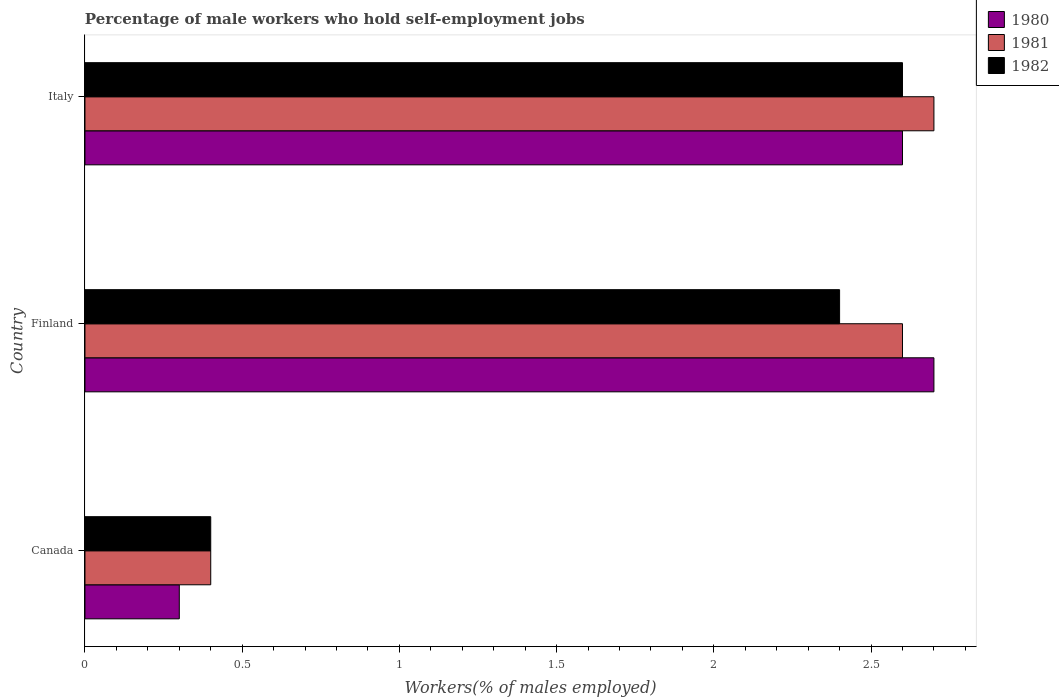How many different coloured bars are there?
Your response must be concise. 3. How many groups of bars are there?
Provide a succinct answer. 3. Are the number of bars per tick equal to the number of legend labels?
Your response must be concise. Yes. How many bars are there on the 3rd tick from the top?
Provide a succinct answer. 3. How many bars are there on the 2nd tick from the bottom?
Provide a short and direct response. 3. What is the label of the 2nd group of bars from the top?
Provide a short and direct response. Finland. In how many cases, is the number of bars for a given country not equal to the number of legend labels?
Provide a short and direct response. 0. What is the percentage of self-employed male workers in 1981 in Italy?
Offer a terse response. 2.7. Across all countries, what is the maximum percentage of self-employed male workers in 1982?
Ensure brevity in your answer.  2.6. Across all countries, what is the minimum percentage of self-employed male workers in 1980?
Your answer should be compact. 0.3. What is the total percentage of self-employed male workers in 1982 in the graph?
Make the answer very short. 5.4. What is the difference between the percentage of self-employed male workers in 1981 in Canada and that in Finland?
Keep it short and to the point. -2.2. What is the difference between the percentage of self-employed male workers in 1981 in Italy and the percentage of self-employed male workers in 1982 in Finland?
Your answer should be very brief. 0.3. What is the average percentage of self-employed male workers in 1980 per country?
Keep it short and to the point. 1.87. What is the difference between the percentage of self-employed male workers in 1981 and percentage of self-employed male workers in 1980 in Canada?
Offer a terse response. 0.1. What is the ratio of the percentage of self-employed male workers in 1982 in Canada to that in Finland?
Ensure brevity in your answer.  0.17. What is the difference between the highest and the second highest percentage of self-employed male workers in 1980?
Your response must be concise. 0.1. What is the difference between the highest and the lowest percentage of self-employed male workers in 1981?
Your answer should be compact. 2.3. In how many countries, is the percentage of self-employed male workers in 1980 greater than the average percentage of self-employed male workers in 1980 taken over all countries?
Give a very brief answer. 2. Is the sum of the percentage of self-employed male workers in 1982 in Canada and Finland greater than the maximum percentage of self-employed male workers in 1980 across all countries?
Make the answer very short. Yes. Are all the bars in the graph horizontal?
Provide a succinct answer. Yes. How many countries are there in the graph?
Provide a short and direct response. 3. Does the graph contain any zero values?
Your response must be concise. No. Does the graph contain grids?
Ensure brevity in your answer.  No. How many legend labels are there?
Give a very brief answer. 3. How are the legend labels stacked?
Ensure brevity in your answer.  Vertical. What is the title of the graph?
Your answer should be compact. Percentage of male workers who hold self-employment jobs. Does "1993" appear as one of the legend labels in the graph?
Offer a very short reply. No. What is the label or title of the X-axis?
Your response must be concise. Workers(% of males employed). What is the Workers(% of males employed) in 1980 in Canada?
Your response must be concise. 0.3. What is the Workers(% of males employed) of 1981 in Canada?
Give a very brief answer. 0.4. What is the Workers(% of males employed) of 1982 in Canada?
Your response must be concise. 0.4. What is the Workers(% of males employed) in 1980 in Finland?
Your response must be concise. 2.7. What is the Workers(% of males employed) in 1981 in Finland?
Offer a terse response. 2.6. What is the Workers(% of males employed) in 1982 in Finland?
Provide a succinct answer. 2.4. What is the Workers(% of males employed) of 1980 in Italy?
Provide a succinct answer. 2.6. What is the Workers(% of males employed) of 1981 in Italy?
Make the answer very short. 2.7. What is the Workers(% of males employed) in 1982 in Italy?
Your answer should be very brief. 2.6. Across all countries, what is the maximum Workers(% of males employed) of 1980?
Give a very brief answer. 2.7. Across all countries, what is the maximum Workers(% of males employed) of 1981?
Provide a succinct answer. 2.7. Across all countries, what is the maximum Workers(% of males employed) in 1982?
Keep it short and to the point. 2.6. Across all countries, what is the minimum Workers(% of males employed) of 1980?
Your answer should be very brief. 0.3. Across all countries, what is the minimum Workers(% of males employed) of 1981?
Give a very brief answer. 0.4. Across all countries, what is the minimum Workers(% of males employed) in 1982?
Your response must be concise. 0.4. What is the total Workers(% of males employed) of 1980 in the graph?
Your response must be concise. 5.6. What is the total Workers(% of males employed) of 1981 in the graph?
Make the answer very short. 5.7. What is the total Workers(% of males employed) of 1982 in the graph?
Provide a succinct answer. 5.4. What is the difference between the Workers(% of males employed) in 1982 in Canada and that in Finland?
Make the answer very short. -2. What is the difference between the Workers(% of males employed) of 1980 in Canada and that in Italy?
Offer a very short reply. -2.3. What is the difference between the Workers(% of males employed) in 1981 in Canada and that in Italy?
Offer a terse response. -2.3. What is the difference between the Workers(% of males employed) of 1982 in Canada and that in Italy?
Make the answer very short. -2.2. What is the difference between the Workers(% of males employed) of 1980 in Finland and that in Italy?
Offer a very short reply. 0.1. What is the difference between the Workers(% of males employed) of 1980 in Canada and the Workers(% of males employed) of 1981 in Finland?
Provide a succinct answer. -2.3. What is the difference between the Workers(% of males employed) of 1980 in Canada and the Workers(% of males employed) of 1982 in Finland?
Your answer should be very brief. -2.1. What is the difference between the Workers(% of males employed) of 1980 in Finland and the Workers(% of males employed) of 1982 in Italy?
Make the answer very short. 0.1. What is the average Workers(% of males employed) in 1980 per country?
Your answer should be very brief. 1.87. What is the average Workers(% of males employed) of 1981 per country?
Your answer should be very brief. 1.9. What is the average Workers(% of males employed) of 1982 per country?
Your answer should be compact. 1.8. What is the difference between the Workers(% of males employed) of 1980 and Workers(% of males employed) of 1981 in Canada?
Your answer should be very brief. -0.1. What is the difference between the Workers(% of males employed) in 1980 and Workers(% of males employed) in 1982 in Canada?
Your response must be concise. -0.1. What is the difference between the Workers(% of males employed) of 1981 and Workers(% of males employed) of 1982 in Canada?
Your answer should be compact. 0. What is the difference between the Workers(% of males employed) of 1981 and Workers(% of males employed) of 1982 in Finland?
Keep it short and to the point. 0.2. What is the difference between the Workers(% of males employed) of 1980 and Workers(% of males employed) of 1982 in Italy?
Offer a terse response. 0. What is the difference between the Workers(% of males employed) of 1981 and Workers(% of males employed) of 1982 in Italy?
Offer a terse response. 0.1. What is the ratio of the Workers(% of males employed) of 1980 in Canada to that in Finland?
Your answer should be compact. 0.11. What is the ratio of the Workers(% of males employed) of 1981 in Canada to that in Finland?
Provide a succinct answer. 0.15. What is the ratio of the Workers(% of males employed) of 1980 in Canada to that in Italy?
Offer a terse response. 0.12. What is the ratio of the Workers(% of males employed) of 1981 in Canada to that in Italy?
Give a very brief answer. 0.15. What is the ratio of the Workers(% of males employed) in 1982 in Canada to that in Italy?
Provide a short and direct response. 0.15. What is the ratio of the Workers(% of males employed) in 1980 in Finland to that in Italy?
Offer a very short reply. 1.04. What is the ratio of the Workers(% of males employed) in 1982 in Finland to that in Italy?
Your answer should be very brief. 0.92. What is the difference between the highest and the second highest Workers(% of males employed) in 1980?
Ensure brevity in your answer.  0.1. What is the difference between the highest and the lowest Workers(% of males employed) of 1982?
Make the answer very short. 2.2. 